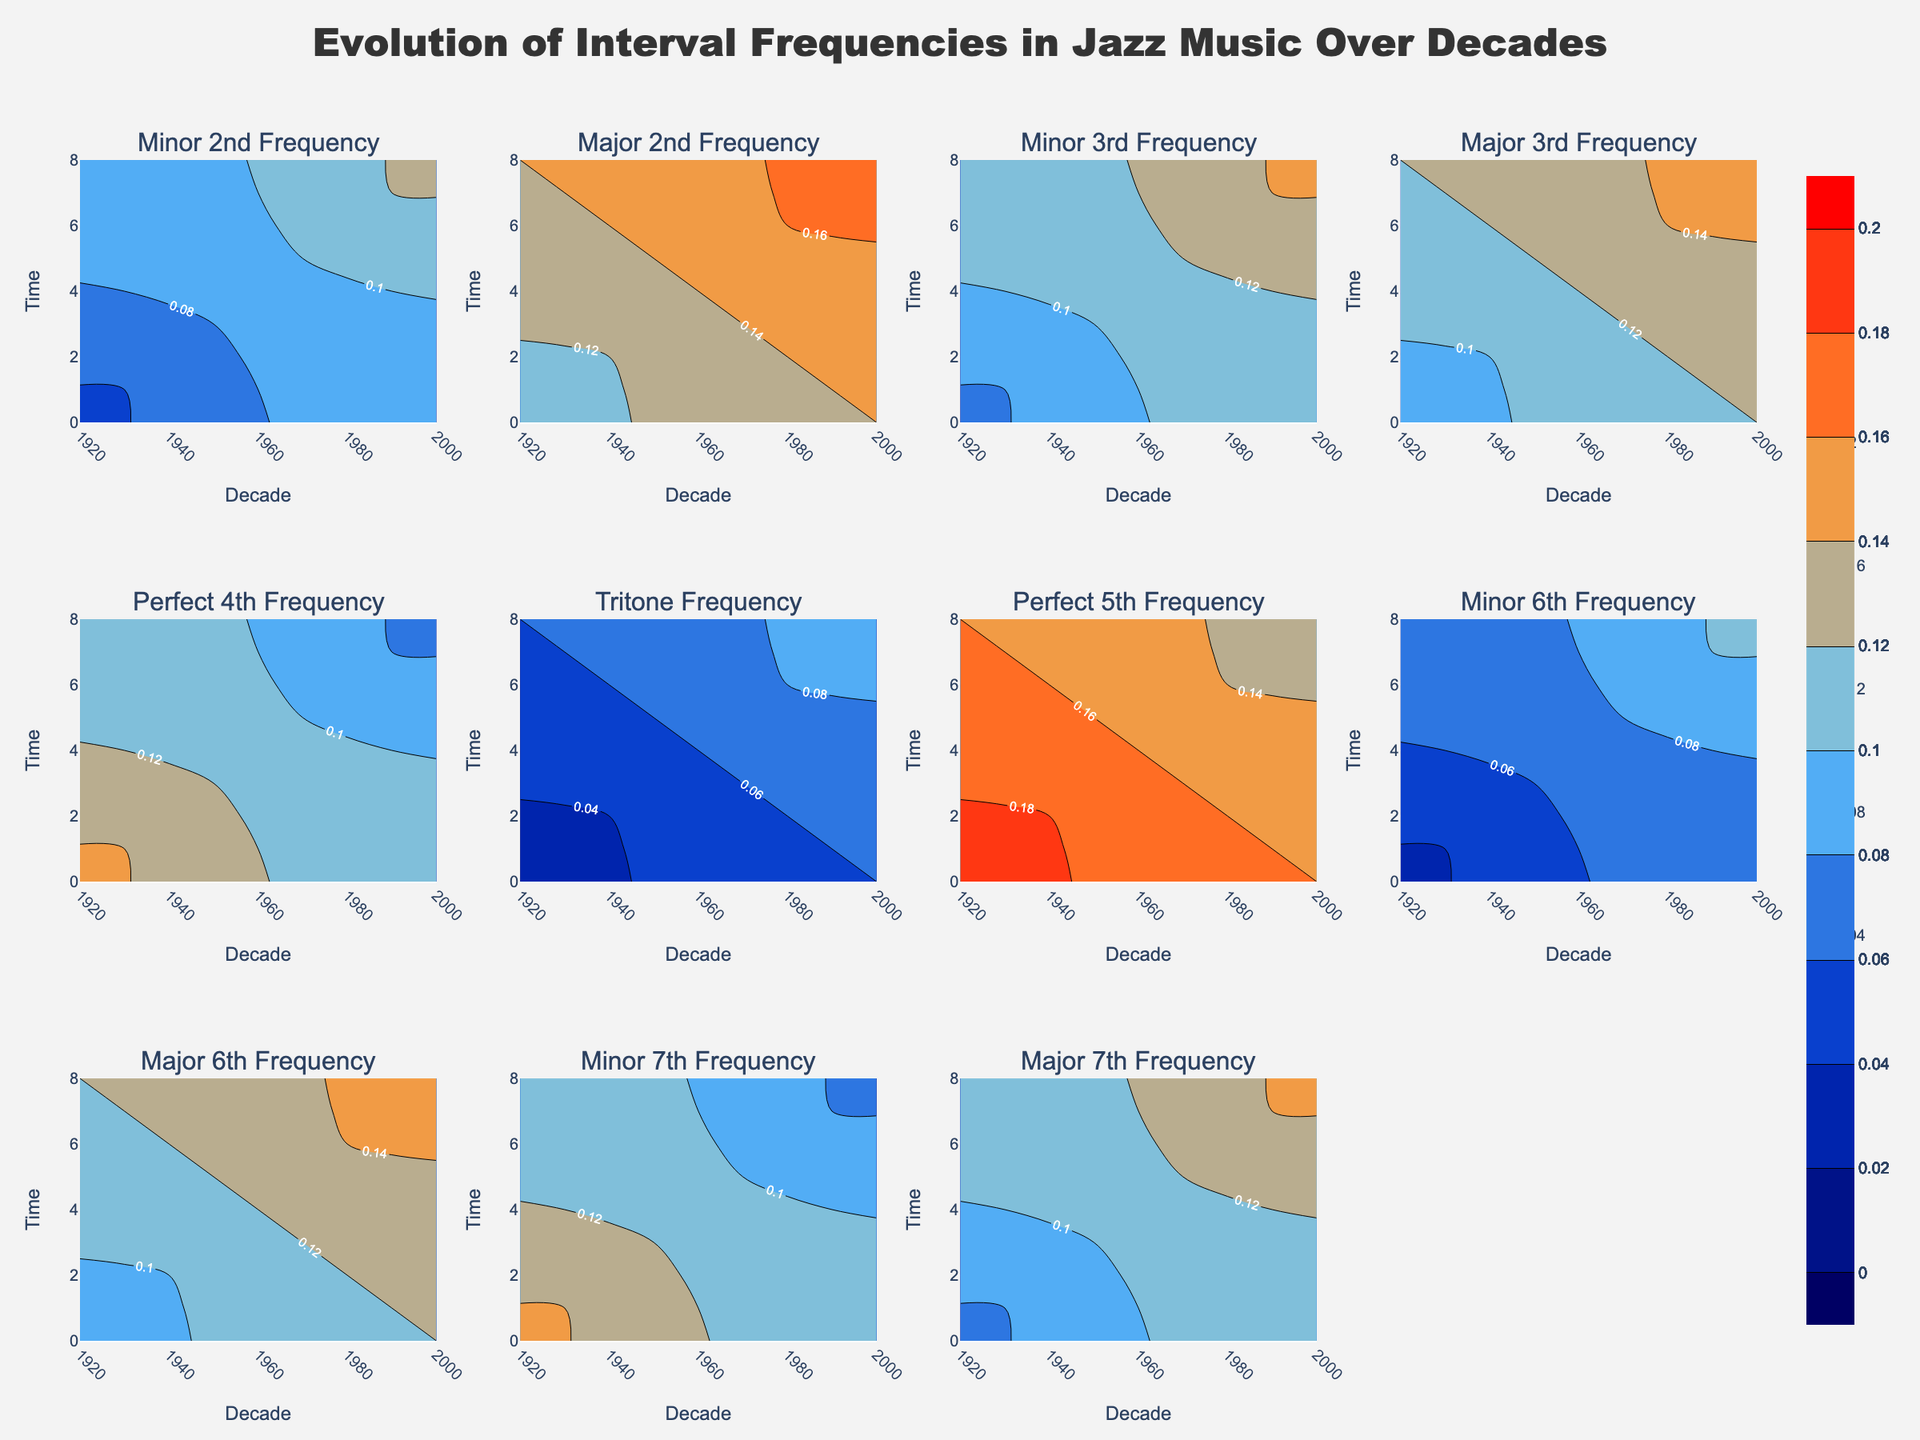What's the title of the figure? The title is placed at the top of the figure in a large font size, making it easily noticeable. It summarizes the content of the figure.
Answer: "Evolution of Interval Frequencies in Jazz Music Over Decades" Which interval has the highest frequency in the 1920s? By looking at the contour plot for the 1920s, we can identify the shades of red (indicating higher frequencies) present. The highest frequency is seen in the Perfect 5th interval with a frequency of 0.20.
Answer: Perfect 5th How did the frequency of the Major 2nd interval change from the 1920s to the 2000s? By examining the contour plot for the Major 2nd interval, the frequency increases over time. It starts at 0.10 in the 1920s and rises to 0.18 in the 2000s.
Answer: It increased from 0.10 to 0.18 Which interval shows the most consistent decrease in frequency over the decades? From the contour plots, we can see that the Perfect 4th interval shows a consistent decrease in frequency, starting at 0.15 in the 1920s and dropping to 0.07 in the 2000s.
Answer: Perfect 4th What is the average frequency of the Minor 7th interval across all decades? Calculate the average of the Minor 7th frequencies, summing them (0.15, 0.14, 0.13, 0.12, 0.11, 0.10, 0.09, 0.08, 0.07) and dividing by the number of decades (9). The sum is 0.99, so the average is 0.99/9 ≈ 0.11
Answer: 0.11 Which interval experienced the largest increase in frequency from the 1920s to the 2000s? Comparing the initial and final frequencies, the Minor 2nd interval has the largest increase, going from 0.05 in the 1920s to 0.13 in the 2000s. The increase is 0.08.
Answer: Minor 2nd What is the general trend of the frequency of Tritone interval over the decades? Observing the contour plot for the Tritone, the frequency steadily increases from 0.02 in the 1920s to 0.10 in the 2000s.
Answer: Steadily increasing Which intervals have more than 0.15 frequency in any decade? From the contour plots, the intervals that achieve a frequency greater than 0.15 in any decade are the Major 2nd, Perfect 5th, and Major 6th intervals.
Answer: Major 2nd, Perfect 5th, Major 6th In which decade did the frequency of the Major 6th interval cross 0.10? Checking the contour plot for Major 6th, we observe that the frequency crossed 0.10 in the 1950s.
Answer: 1950s 